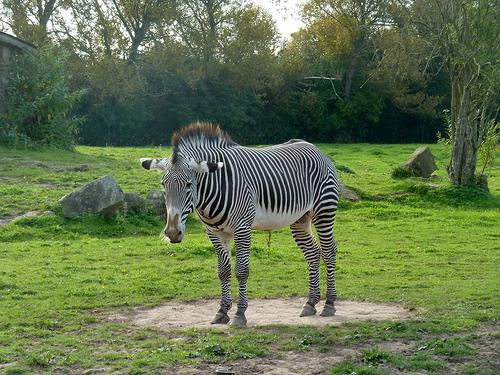Question: what is this animal called?
Choices:
A. Giraffe.
B. Zebra.
C. Elephant.
D. Animals.
Answer with the letter. Answer: B Question: when was this picture taken?
Choices:
A. During the day.
B. Noon.
C. Mid day.
D. Early.
Answer with the letter. Answer: A Question: who is the focus of the picture?
Choices:
A. The zebra.
B. Giraffe.
C. Animal.
D. Horse.
Answer with the letter. Answer: A Question: what type of animal is a zebra?
Choices:
A. A big one.
B. Mammal.
C. Striped on.
D. Four legged one.
Answer with the letter. Answer: B 